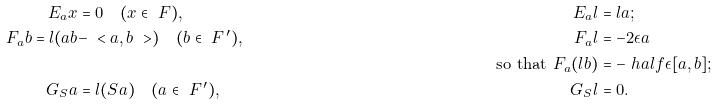<formula> <loc_0><loc_0><loc_500><loc_500>E _ { a } x & = 0 \quad ( x \in \ F ) , & E _ { a } l & = l a ; \\ F _ { a } b = l ( a b & - \ < a , b \ > ) \quad ( b \in \ F ^ { \, \prime } ) , & F _ { a } l & = - 2 \epsilon a \\ & & \text {so that } F _ { a } ( l b ) & = - \ h a l f \epsilon [ a , b ] ; \\ G _ { S } a & = l ( S a ) \quad ( a \in \ F ^ { \, \prime } ) , & G _ { S } l & = 0 .</formula> 